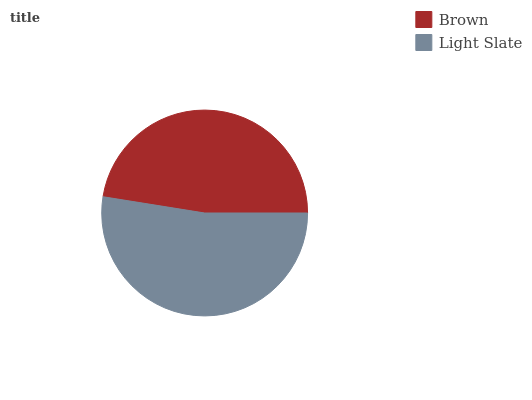Is Brown the minimum?
Answer yes or no. Yes. Is Light Slate the maximum?
Answer yes or no. Yes. Is Light Slate the minimum?
Answer yes or no. No. Is Light Slate greater than Brown?
Answer yes or no. Yes. Is Brown less than Light Slate?
Answer yes or no. Yes. Is Brown greater than Light Slate?
Answer yes or no. No. Is Light Slate less than Brown?
Answer yes or no. No. Is Light Slate the high median?
Answer yes or no. Yes. Is Brown the low median?
Answer yes or no. Yes. Is Brown the high median?
Answer yes or no. No. Is Light Slate the low median?
Answer yes or no. No. 